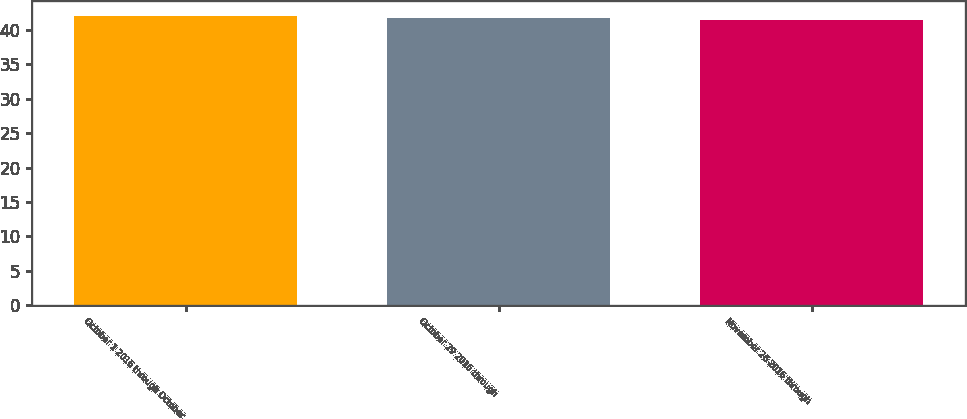<chart> <loc_0><loc_0><loc_500><loc_500><bar_chart><fcel>October 1 2016 through October<fcel>October 29 2016 through<fcel>November 26 2016 through<nl><fcel>42.1<fcel>41.71<fcel>41.42<nl></chart> 